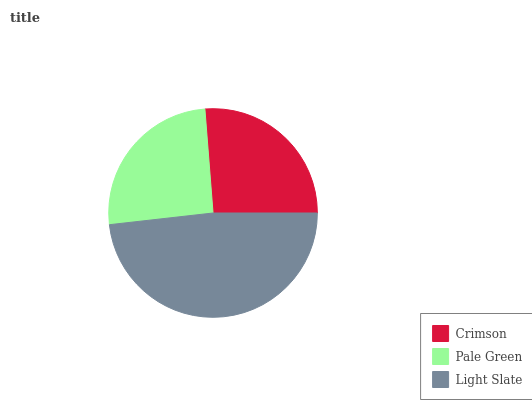Is Pale Green the minimum?
Answer yes or no. Yes. Is Light Slate the maximum?
Answer yes or no. Yes. Is Light Slate the minimum?
Answer yes or no. No. Is Pale Green the maximum?
Answer yes or no. No. Is Light Slate greater than Pale Green?
Answer yes or no. Yes. Is Pale Green less than Light Slate?
Answer yes or no. Yes. Is Pale Green greater than Light Slate?
Answer yes or no. No. Is Light Slate less than Pale Green?
Answer yes or no. No. Is Crimson the high median?
Answer yes or no. Yes. Is Crimson the low median?
Answer yes or no. Yes. Is Light Slate the high median?
Answer yes or no. No. Is Light Slate the low median?
Answer yes or no. No. 